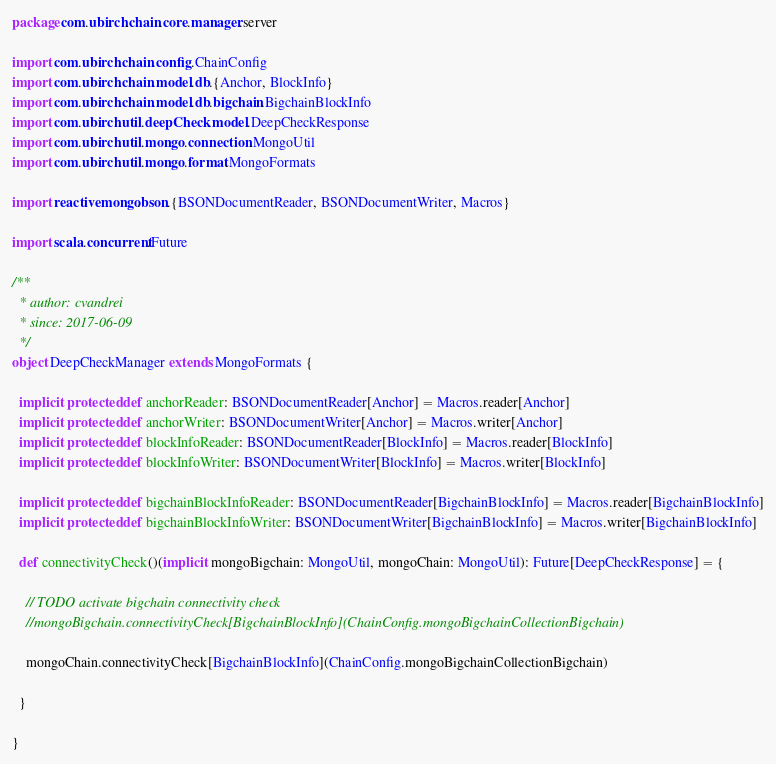Convert code to text. <code><loc_0><loc_0><loc_500><loc_500><_Scala_>package com.ubirch.chain.core.manager.server

import com.ubirch.chain.config.ChainConfig
import com.ubirch.chain.model.db.{Anchor, BlockInfo}
import com.ubirch.chain.model.db.bigchain.BigchainBlockInfo
import com.ubirch.util.deepCheck.model.DeepCheckResponse
import com.ubirch.util.mongo.connection.MongoUtil
import com.ubirch.util.mongo.format.MongoFormats

import reactivemongo.bson.{BSONDocumentReader, BSONDocumentWriter, Macros}

import scala.concurrent.Future

/**
  * author: cvandrei
  * since: 2017-06-09
  */
object DeepCheckManager extends MongoFormats {

  implicit protected def anchorReader: BSONDocumentReader[Anchor] = Macros.reader[Anchor]
  implicit protected def anchorWriter: BSONDocumentWriter[Anchor] = Macros.writer[Anchor]
  implicit protected def blockInfoReader: BSONDocumentReader[BlockInfo] = Macros.reader[BlockInfo]
  implicit protected def blockInfoWriter: BSONDocumentWriter[BlockInfo] = Macros.writer[BlockInfo]

  implicit protected def bigchainBlockInfoReader: BSONDocumentReader[BigchainBlockInfo] = Macros.reader[BigchainBlockInfo]
  implicit protected def bigchainBlockInfoWriter: BSONDocumentWriter[BigchainBlockInfo] = Macros.writer[BigchainBlockInfo]

  def connectivityCheck()(implicit mongoBigchain: MongoUtil, mongoChain: MongoUtil): Future[DeepCheckResponse] = {

    // TODO activate bigchain connectivity check
    //mongoBigchain.connectivityCheck[BigchainBlockInfo](ChainConfig.mongoBigchainCollectionBigchain)

    mongoChain.connectivityCheck[BigchainBlockInfo](ChainConfig.mongoBigchainCollectionBigchain)

  }

}
</code> 